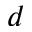Convert formula to latex. <formula><loc_0><loc_0><loc_500><loc_500>d</formula> 